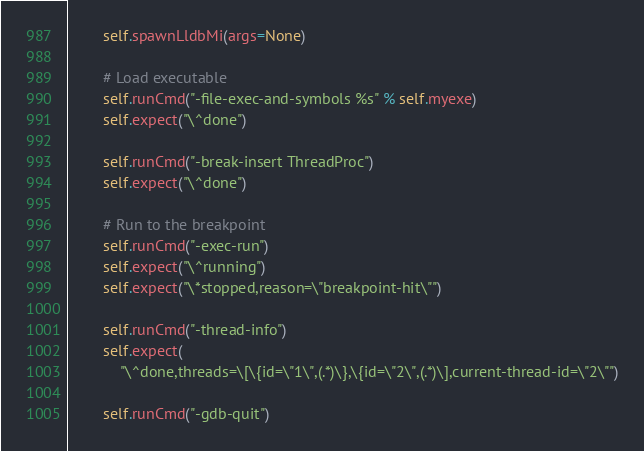<code> <loc_0><loc_0><loc_500><loc_500><_Python_>
        self.spawnLldbMi(args=None)

        # Load executable
        self.runCmd("-file-exec-and-symbols %s" % self.myexe)
        self.expect("\^done")

        self.runCmd("-break-insert ThreadProc")
        self.expect("\^done")

        # Run to the breakpoint
        self.runCmd("-exec-run")
        self.expect("\^running")
        self.expect("\*stopped,reason=\"breakpoint-hit\"")

        self.runCmd("-thread-info")
        self.expect(
            "\^done,threads=\[\{id=\"1\",(.*)\},\{id=\"2\",(.*)\],current-thread-id=\"2\"")

        self.runCmd("-gdb-quit")
</code> 